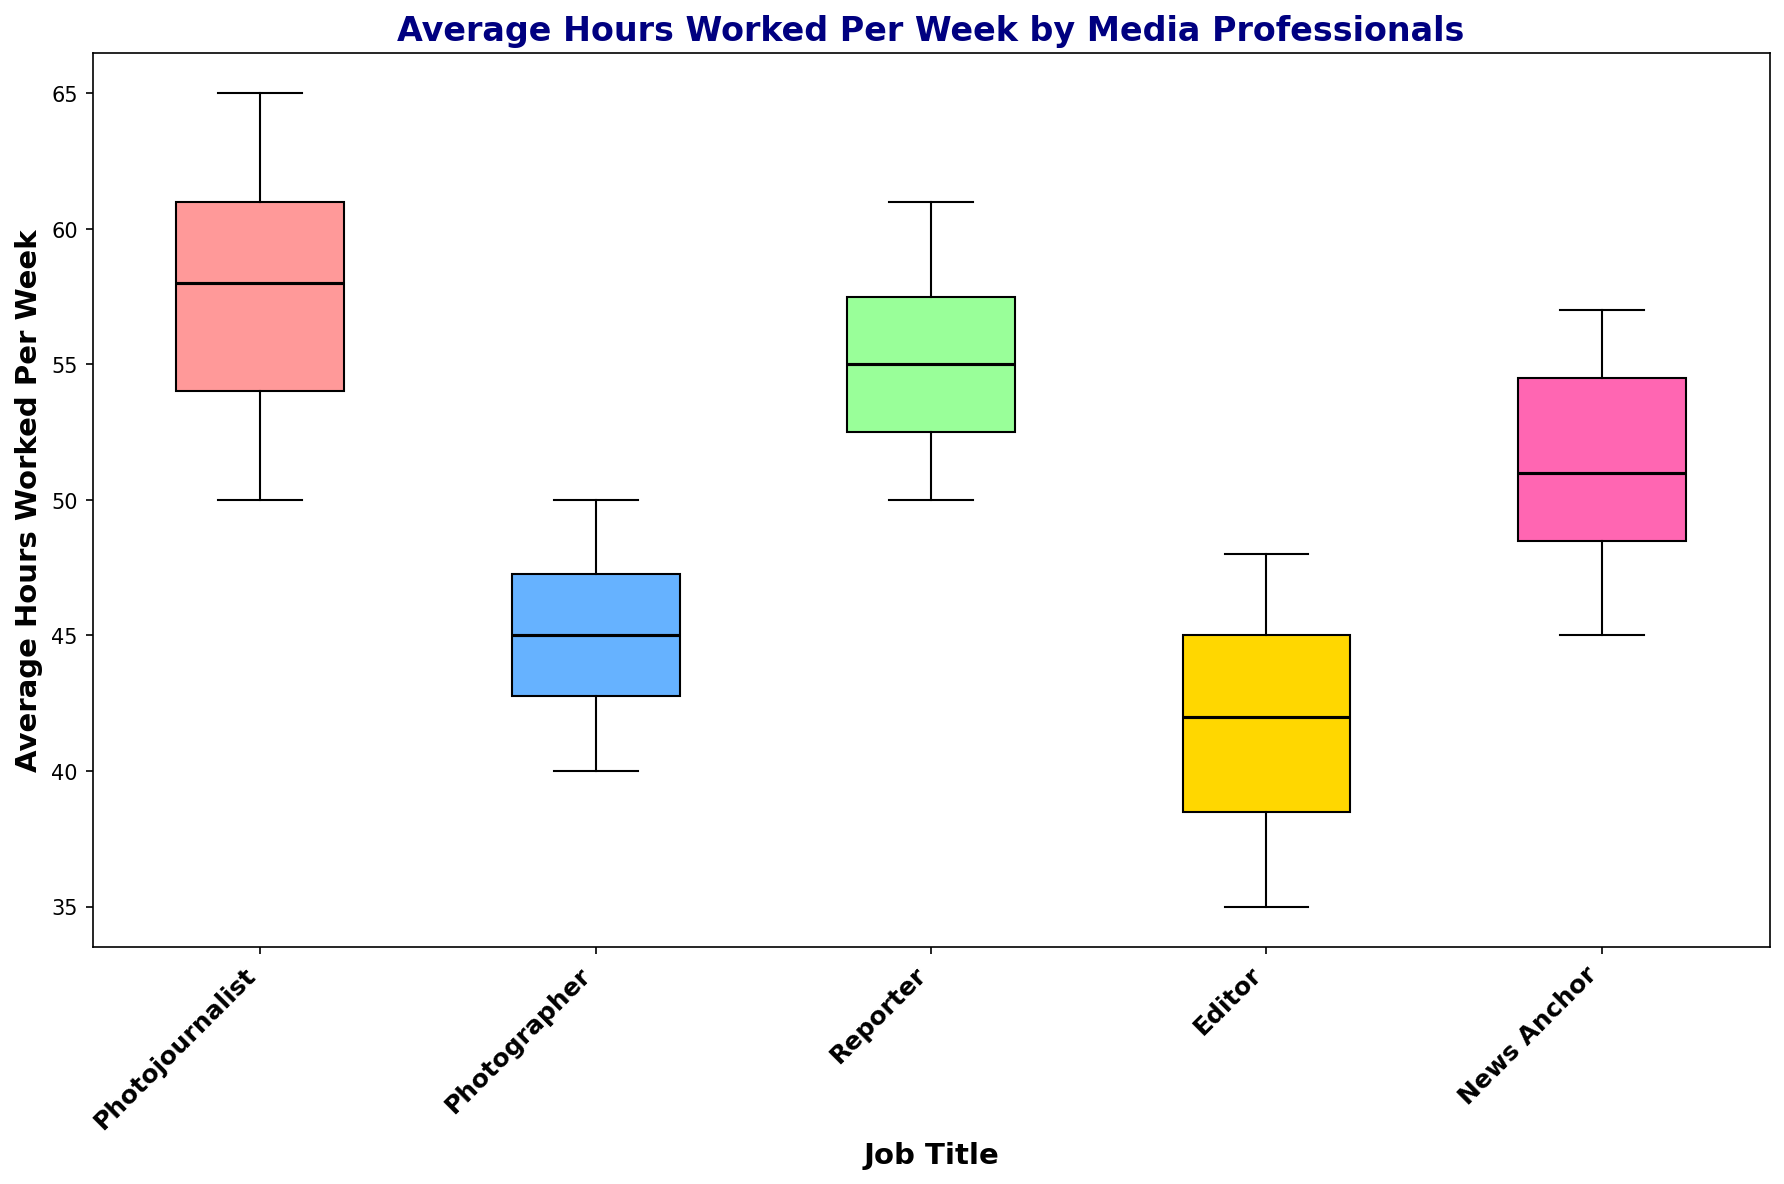What's the median value of hours worked per week by Photojournalists? To find the median, observe the center value in the sorted list of "Photojournalist" data points, which are {50, 51, 52, 53, 54, 55, 56, 57, 58, 59, 60, 60, 61, 62, 63, 64, 65}. The middle value (n=17, median is the 9th value) is 57.
Answer: 57 Which job title has the widest range of hours worked? To determine the range, find the difference between the maximum and minimum values for each job title; Photojournalists: 65-50=15, Photographers: 50-40=10, Reporters: 61-50=11, Editors: 48-35=13, News Anchors: 57-45=12. Photojournalists have the widest range of 15 hours.
Answer: Photojournalist Which job title typically works the least amount of hours per week, based on the median? The median value of hours worked per job title: Photojournalist=57, Photographer=45, Reporter=54, Editor=42, News Anchor=51. Editors have the smallest median at 42 hours.
Answer: Editor Which job titles have hours worked with similar visual spreads and ranges? Compare the boxes and whiskers for visual similarities; Editors and Photographers both have visually smaller ranges compared to other titles, indicating similar distributions.
Answer: Editor and Photographer What is the 75th percentile (upper quartile) of hours worked for Reporters? The upper quartile is the median of the second half of the Reporter's sorted data: {50, 51, 52, 52, 53, 53, 54, 55, 55, 56, 57, 58, 59, 60, 61}. The middle value of {55, 56, 57, 58, 59, 60, 61} is 58, so the 75th percentile is 58 hours.
Answer: 58 Which job title has the highest upper whisker in the box plot? The highest upper whisker indicates the job title with the highest maximum value; Photojournalists have the highest upper whisker extending to 65 hours.
Answer: Photojournalist Do Photographers tend to work more or fewer hours per week compared to News Anchors based on the interquartile range (IQR)? Calculate the IQR (Q3-Q1) for both; Photographers have IQR: 48-43=5, News Anchors have IQR: 53-47=6. News Anchors have a larger IQR, indicating more spread but, on average, work more hours.
Answer: More hours How do the median hours worked by Reporters compare to those of News Anchors? The median for Reporters (54 hours) is compared to the median for News Anchors (51 hours). Reporters have a higher median.
Answer: Reporters work more What does the length of the box in the box plot represent and how does it vary among the job titles? The length of a box represents the interquartile range (IQR), showing the middle 50% of data; Reporters and News Anchors have larger boxes compared to Photographers and Editors, indicating more variation in their work hours.
Answer: It varies by showing the IQR Based on the box plot, what can be inferred about the outliers in terms of hours worked per week? Outliers are shown as points outside the whiskers; visually inspect for extreme values outside usual ranges. The job titles in the plot seem well within their whiskers, without significant outliers differentiating job titles' working hours.
Answer: No significant outliers 